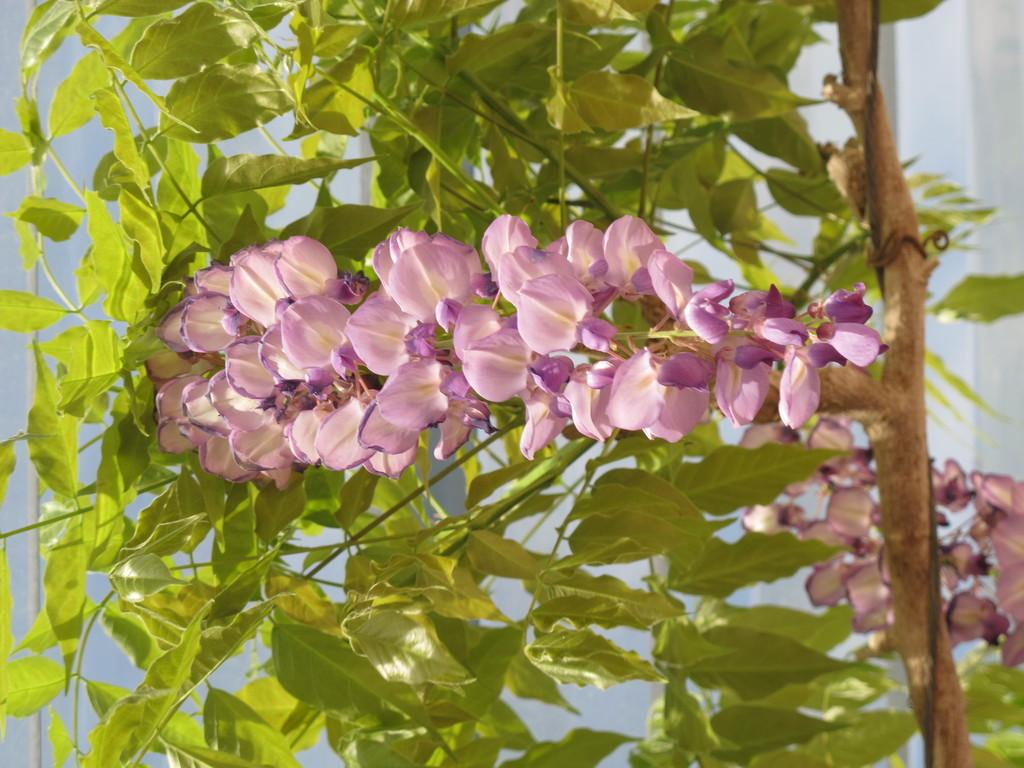What type of living organisms can be seen in the image? Plants and flowers are visible in the image. Can you describe the flowers in the image? The flowers in the image are part of the plants and are likely blooming. What type of authority figure can be seen in the image? There is no authority figure present in the image; it features plants and flowers. Can you tell me where the nest is located in the image? There is no nest present in the image; it features plants and flowers. 